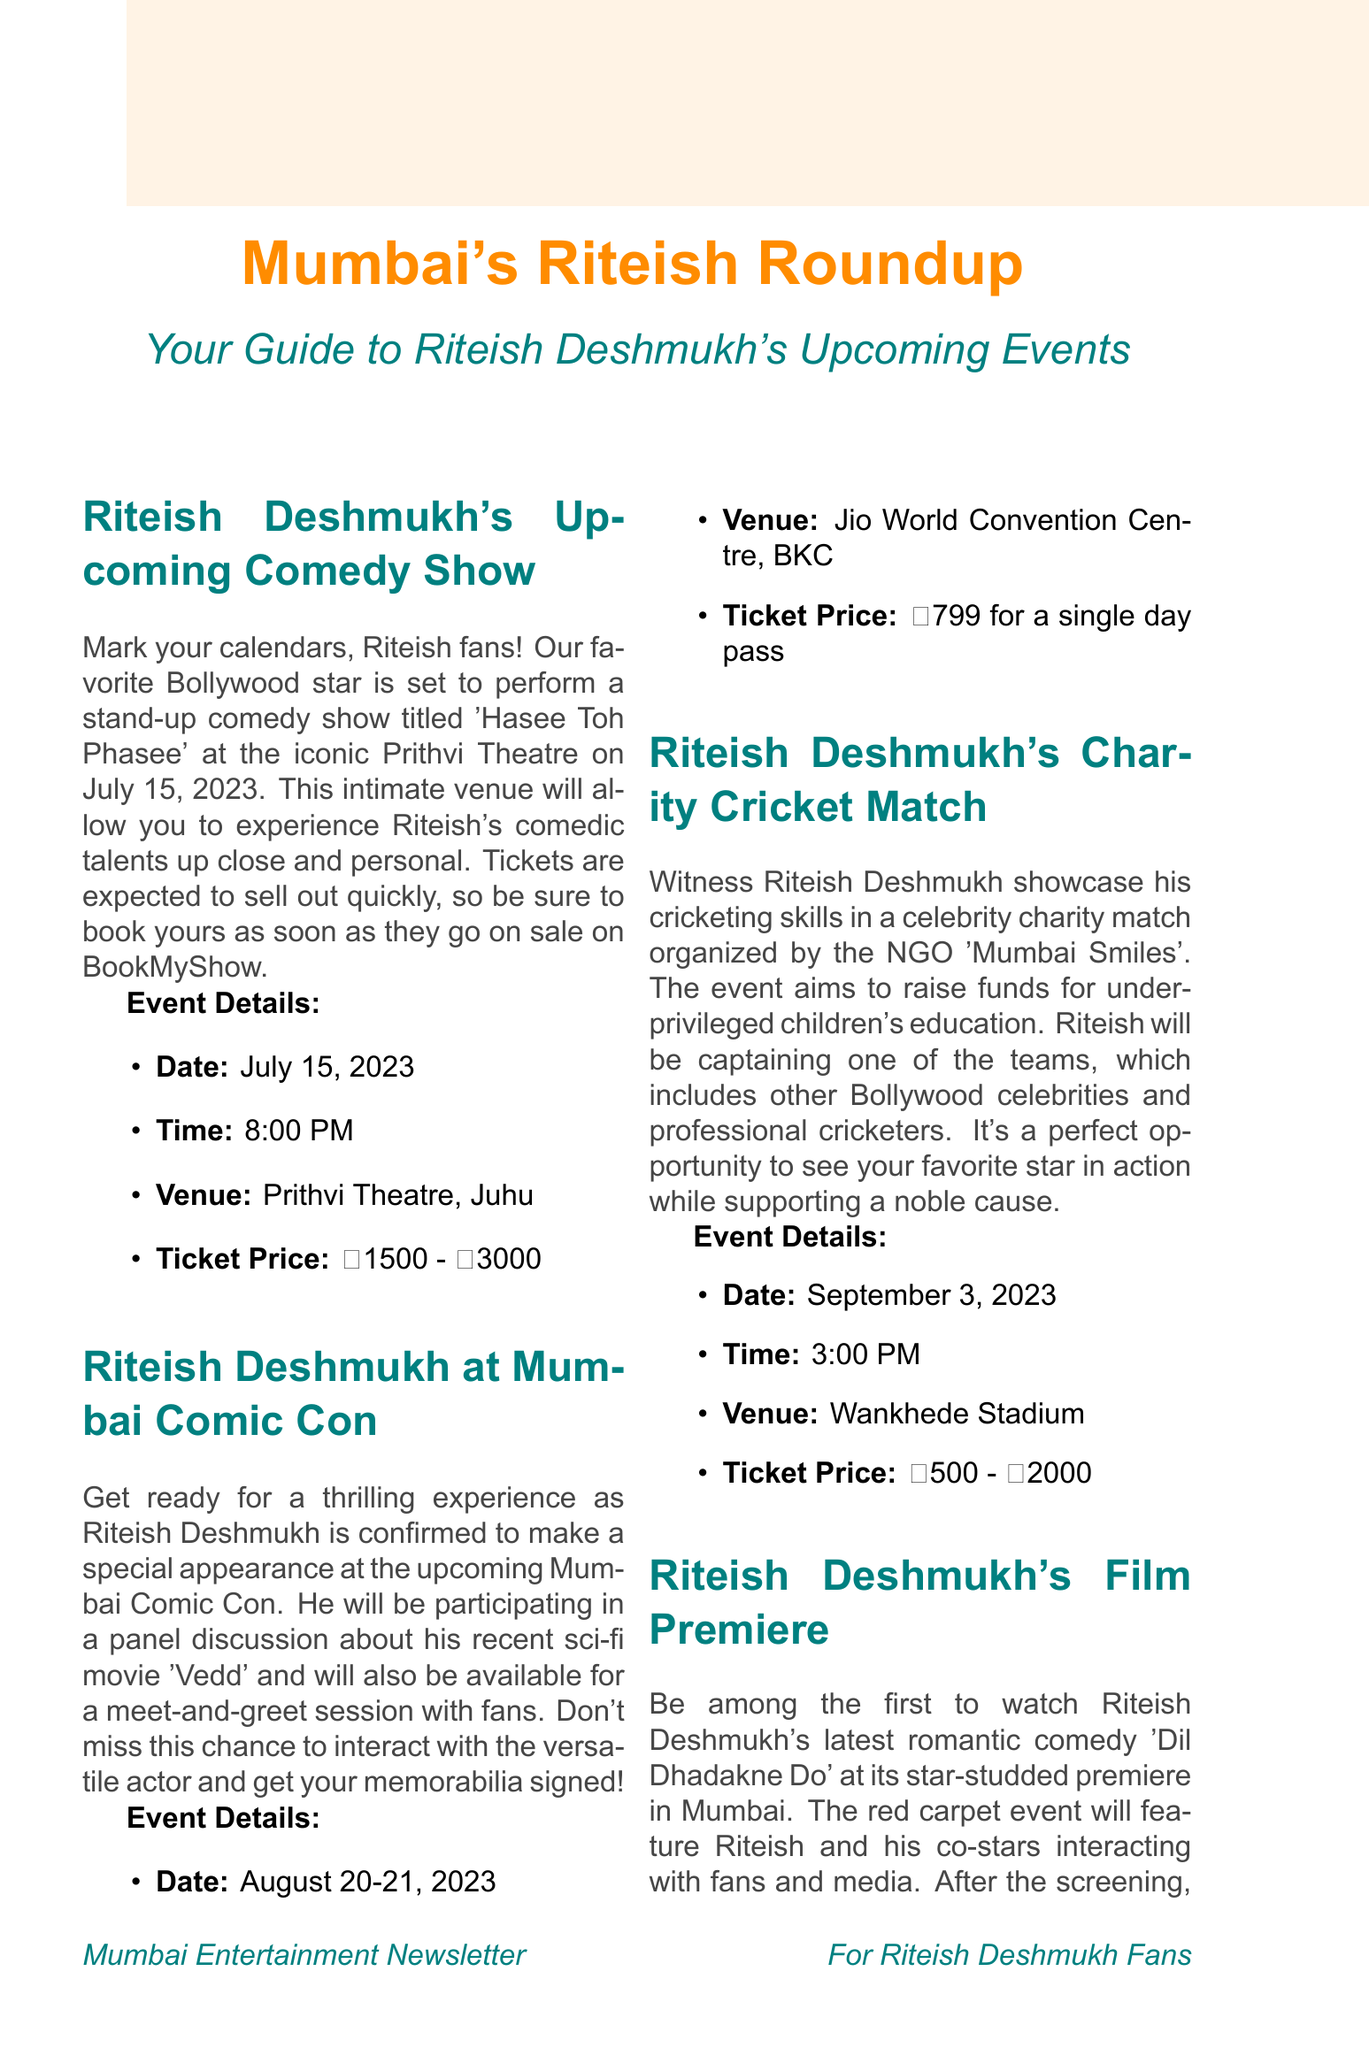What is the date of Riteish Deshmukh's comedy show? The document states that the comedy show is scheduled for July 15, 2023.
Answer: July 15, 2023 Where is the Mumbai Comic Con being held? The venue for the Mumbai Comic Con is mentioned as Jio World Convention Centre, BKC.
Answer: Jio World Convention Centre, BKC What is the ticket price range for Riteish Deshmukh's charity cricket match? The document outlines that the ticket prices for the charity cricket match range from ₹500 to ₹2000.
Answer: ₹500 - ₹2000 What event is Riteish Deshmukh attending on November 12, 2023? The document indicates that Riteish Deshmukh will be at the Mumbai International Film Festival on this date.
Answer: Mumbai International Film Festival What activity will Riteish Deshmukh be engaged in at the Mumbai Comic Con? The document mentions that he will be participating in a panel discussion about his recent sci-fi movie 'Vedd'.
Answer: Panel discussion What is unique about the entry to Riteish Deshmukh's film premiere? The document specifies that attendance to the film premiere is by invitation only, which is unique compared to the other events.
Answer: By invitation only How long is the masterclass conducted by Riteish Deshmukh at MIFF? The document states that the masterclass is scheduled from 11:00 AM to 1:00 PM, indicating a duration of 2 hours.
Answer: 2 hours On what date will Riteish Deshmukh's latest romantic comedy premiere? According to the document, the premiere date of the romantic comedy 'Dil Dhadakne Do' is October 5, 2023.
Answer: October 5, 2023 What cause is being supported by the charity cricket match? The document mentions that the charity cricket match aims to raise funds for underprivileged children's education.
Answer: Underprivileged children's education 